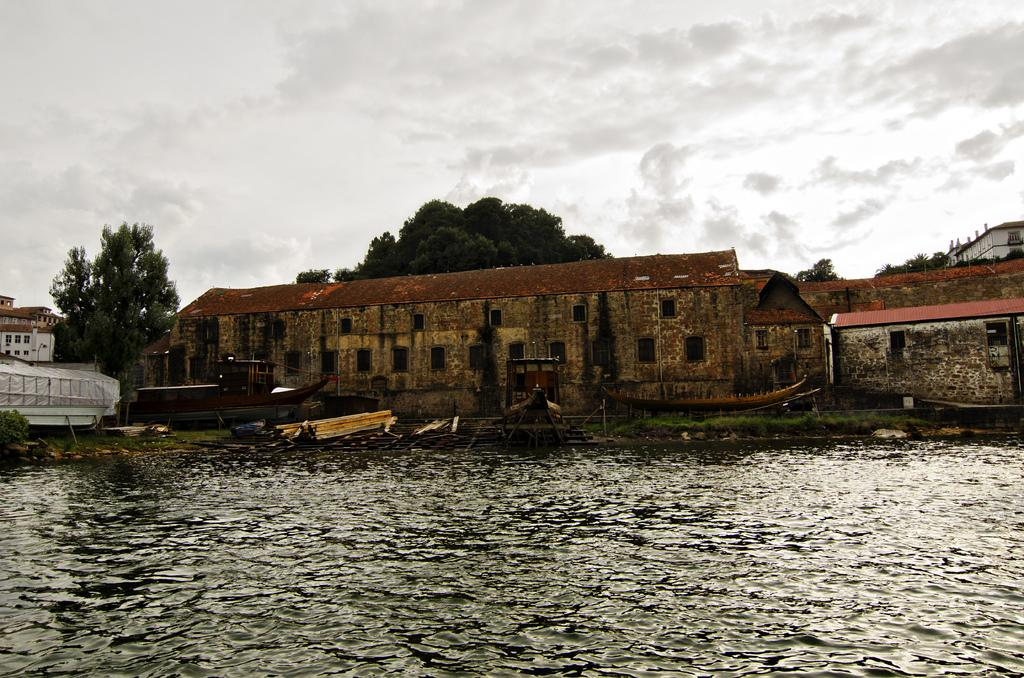What type of structures can be seen in the image? There are buildings in the image. What feature do the buildings have? The buildings have windows. What natural element is visible in the image? There is water visible in the image. What is present in the water? There are boats in the water. What type of vegetation can be seen in the image? There are trees in the image. What is the color of the sky in the image? The sky is white in color. What type of meal is being prepared by the carpenter in the image? There is no carpenter or meal preparation present in the image. What type of driving is taking place in the image? There is no driving or vehicles present in the image. 